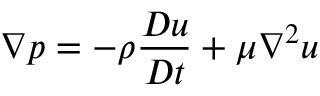Convert formula to latex. <formula><loc_0><loc_0><loc_500><loc_500>\nabla p = - \rho \frac { D u } { D t } + \mu \nabla ^ { 2 } u</formula> 